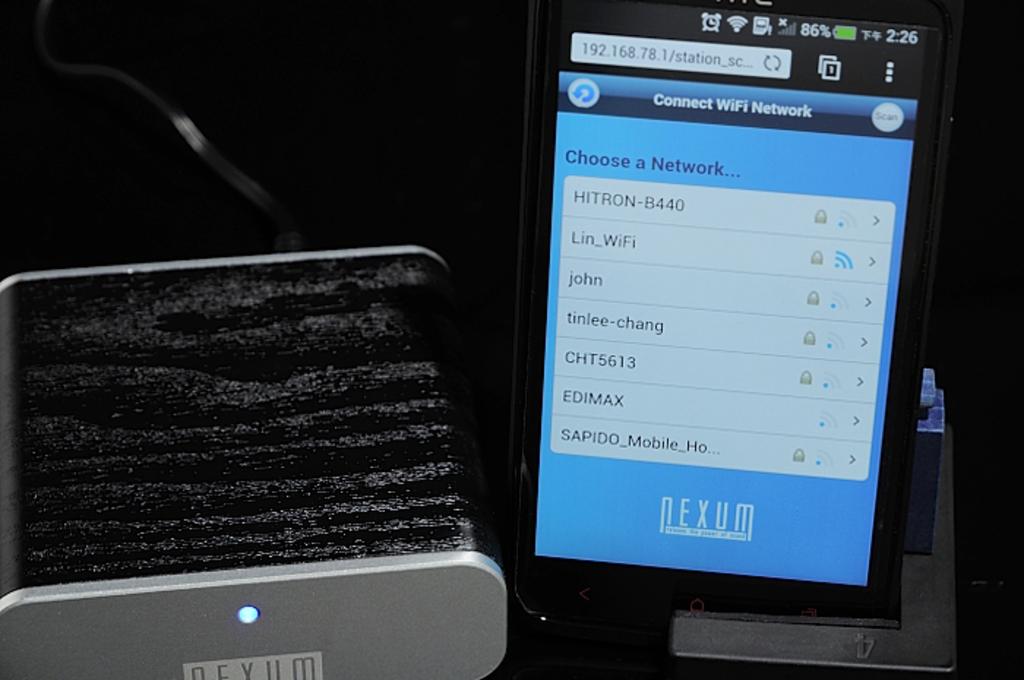Is every wifi spots are free from password?
Make the answer very short. No. What menu is being displayed?
Your response must be concise. Wifi menu. 